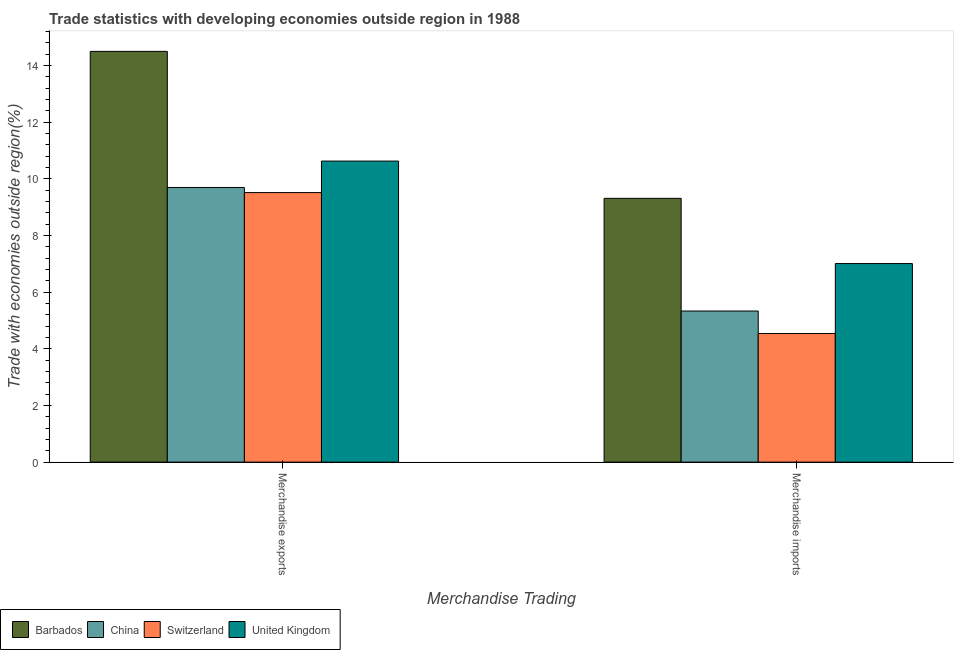How many groups of bars are there?
Keep it short and to the point. 2. Are the number of bars per tick equal to the number of legend labels?
Keep it short and to the point. Yes. How many bars are there on the 2nd tick from the left?
Provide a short and direct response. 4. What is the label of the 2nd group of bars from the left?
Make the answer very short. Merchandise imports. What is the merchandise imports in Switzerland?
Offer a terse response. 4.54. Across all countries, what is the maximum merchandise imports?
Offer a terse response. 9.31. Across all countries, what is the minimum merchandise imports?
Your answer should be very brief. 4.54. In which country was the merchandise exports maximum?
Your answer should be very brief. Barbados. In which country was the merchandise exports minimum?
Give a very brief answer. Switzerland. What is the total merchandise exports in the graph?
Keep it short and to the point. 44.32. What is the difference between the merchandise imports in United Kingdom and that in China?
Ensure brevity in your answer.  1.68. What is the difference between the merchandise exports in China and the merchandise imports in Barbados?
Make the answer very short. 0.38. What is the average merchandise imports per country?
Make the answer very short. 6.55. What is the difference between the merchandise exports and merchandise imports in Switzerland?
Make the answer very short. 4.97. In how many countries, is the merchandise exports greater than 12.4 %?
Keep it short and to the point. 1. What is the ratio of the merchandise exports in China to that in United Kingdom?
Give a very brief answer. 0.91. In how many countries, is the merchandise exports greater than the average merchandise exports taken over all countries?
Offer a very short reply. 1. What does the 3rd bar from the left in Merchandise imports represents?
Your response must be concise. Switzerland. What does the 3rd bar from the right in Merchandise exports represents?
Ensure brevity in your answer.  China. How many bars are there?
Provide a short and direct response. 8. Are all the bars in the graph horizontal?
Give a very brief answer. No. How many countries are there in the graph?
Your response must be concise. 4. Does the graph contain any zero values?
Give a very brief answer. No. Does the graph contain grids?
Give a very brief answer. No. How many legend labels are there?
Give a very brief answer. 4. What is the title of the graph?
Your answer should be compact. Trade statistics with developing economies outside region in 1988. Does "Costa Rica" appear as one of the legend labels in the graph?
Give a very brief answer. No. What is the label or title of the X-axis?
Your answer should be compact. Merchandise Trading. What is the label or title of the Y-axis?
Provide a short and direct response. Trade with economies outside region(%). What is the Trade with economies outside region(%) in Barbados in Merchandise exports?
Your answer should be very brief. 14.49. What is the Trade with economies outside region(%) in China in Merchandise exports?
Your answer should be very brief. 9.69. What is the Trade with economies outside region(%) in Switzerland in Merchandise exports?
Give a very brief answer. 9.51. What is the Trade with economies outside region(%) of United Kingdom in Merchandise exports?
Make the answer very short. 10.62. What is the Trade with economies outside region(%) in Barbados in Merchandise imports?
Ensure brevity in your answer.  9.31. What is the Trade with economies outside region(%) of China in Merchandise imports?
Provide a succinct answer. 5.33. What is the Trade with economies outside region(%) in Switzerland in Merchandise imports?
Your answer should be very brief. 4.54. What is the Trade with economies outside region(%) in United Kingdom in Merchandise imports?
Offer a terse response. 7.01. Across all Merchandise Trading, what is the maximum Trade with economies outside region(%) of Barbados?
Your response must be concise. 14.49. Across all Merchandise Trading, what is the maximum Trade with economies outside region(%) of China?
Offer a very short reply. 9.69. Across all Merchandise Trading, what is the maximum Trade with economies outside region(%) of Switzerland?
Give a very brief answer. 9.51. Across all Merchandise Trading, what is the maximum Trade with economies outside region(%) in United Kingdom?
Give a very brief answer. 10.62. Across all Merchandise Trading, what is the minimum Trade with economies outside region(%) of Barbados?
Offer a terse response. 9.31. Across all Merchandise Trading, what is the minimum Trade with economies outside region(%) of China?
Your response must be concise. 5.33. Across all Merchandise Trading, what is the minimum Trade with economies outside region(%) in Switzerland?
Your answer should be compact. 4.54. Across all Merchandise Trading, what is the minimum Trade with economies outside region(%) in United Kingdom?
Keep it short and to the point. 7.01. What is the total Trade with economies outside region(%) of Barbados in the graph?
Ensure brevity in your answer.  23.8. What is the total Trade with economies outside region(%) in China in the graph?
Offer a terse response. 15.02. What is the total Trade with economies outside region(%) of Switzerland in the graph?
Give a very brief answer. 14.05. What is the total Trade with economies outside region(%) in United Kingdom in the graph?
Ensure brevity in your answer.  17.63. What is the difference between the Trade with economies outside region(%) in Barbados in Merchandise exports and that in Merchandise imports?
Make the answer very short. 5.19. What is the difference between the Trade with economies outside region(%) of China in Merchandise exports and that in Merchandise imports?
Provide a short and direct response. 4.36. What is the difference between the Trade with economies outside region(%) in Switzerland in Merchandise exports and that in Merchandise imports?
Your answer should be compact. 4.97. What is the difference between the Trade with economies outside region(%) of United Kingdom in Merchandise exports and that in Merchandise imports?
Provide a succinct answer. 3.62. What is the difference between the Trade with economies outside region(%) in Barbados in Merchandise exports and the Trade with economies outside region(%) in China in Merchandise imports?
Make the answer very short. 9.16. What is the difference between the Trade with economies outside region(%) in Barbados in Merchandise exports and the Trade with economies outside region(%) in Switzerland in Merchandise imports?
Make the answer very short. 9.96. What is the difference between the Trade with economies outside region(%) of Barbados in Merchandise exports and the Trade with economies outside region(%) of United Kingdom in Merchandise imports?
Give a very brief answer. 7.49. What is the difference between the Trade with economies outside region(%) in China in Merchandise exports and the Trade with economies outside region(%) in Switzerland in Merchandise imports?
Keep it short and to the point. 5.15. What is the difference between the Trade with economies outside region(%) in China in Merchandise exports and the Trade with economies outside region(%) in United Kingdom in Merchandise imports?
Provide a short and direct response. 2.68. What is the difference between the Trade with economies outside region(%) of Switzerland in Merchandise exports and the Trade with economies outside region(%) of United Kingdom in Merchandise imports?
Your answer should be compact. 2.5. What is the average Trade with economies outside region(%) in Barbados per Merchandise Trading?
Make the answer very short. 11.9. What is the average Trade with economies outside region(%) in China per Merchandise Trading?
Provide a short and direct response. 7.51. What is the average Trade with economies outside region(%) of Switzerland per Merchandise Trading?
Offer a very short reply. 7.03. What is the average Trade with economies outside region(%) of United Kingdom per Merchandise Trading?
Offer a very short reply. 8.81. What is the difference between the Trade with economies outside region(%) of Barbados and Trade with economies outside region(%) of China in Merchandise exports?
Keep it short and to the point. 4.8. What is the difference between the Trade with economies outside region(%) of Barbados and Trade with economies outside region(%) of Switzerland in Merchandise exports?
Offer a terse response. 4.98. What is the difference between the Trade with economies outside region(%) in Barbados and Trade with economies outside region(%) in United Kingdom in Merchandise exports?
Give a very brief answer. 3.87. What is the difference between the Trade with economies outside region(%) in China and Trade with economies outside region(%) in Switzerland in Merchandise exports?
Your response must be concise. 0.18. What is the difference between the Trade with economies outside region(%) of China and Trade with economies outside region(%) of United Kingdom in Merchandise exports?
Offer a terse response. -0.93. What is the difference between the Trade with economies outside region(%) of Switzerland and Trade with economies outside region(%) of United Kingdom in Merchandise exports?
Your answer should be compact. -1.11. What is the difference between the Trade with economies outside region(%) of Barbados and Trade with economies outside region(%) of China in Merchandise imports?
Give a very brief answer. 3.98. What is the difference between the Trade with economies outside region(%) in Barbados and Trade with economies outside region(%) in Switzerland in Merchandise imports?
Your response must be concise. 4.77. What is the difference between the Trade with economies outside region(%) of Barbados and Trade with economies outside region(%) of United Kingdom in Merchandise imports?
Keep it short and to the point. 2.3. What is the difference between the Trade with economies outside region(%) in China and Trade with economies outside region(%) in Switzerland in Merchandise imports?
Your answer should be very brief. 0.79. What is the difference between the Trade with economies outside region(%) of China and Trade with economies outside region(%) of United Kingdom in Merchandise imports?
Give a very brief answer. -1.68. What is the difference between the Trade with economies outside region(%) in Switzerland and Trade with economies outside region(%) in United Kingdom in Merchandise imports?
Your response must be concise. -2.47. What is the ratio of the Trade with economies outside region(%) of Barbados in Merchandise exports to that in Merchandise imports?
Provide a short and direct response. 1.56. What is the ratio of the Trade with economies outside region(%) of China in Merchandise exports to that in Merchandise imports?
Provide a short and direct response. 1.82. What is the ratio of the Trade with economies outside region(%) in Switzerland in Merchandise exports to that in Merchandise imports?
Your response must be concise. 2.1. What is the ratio of the Trade with economies outside region(%) of United Kingdom in Merchandise exports to that in Merchandise imports?
Keep it short and to the point. 1.52. What is the difference between the highest and the second highest Trade with economies outside region(%) in Barbados?
Keep it short and to the point. 5.19. What is the difference between the highest and the second highest Trade with economies outside region(%) of China?
Your answer should be very brief. 4.36. What is the difference between the highest and the second highest Trade with economies outside region(%) of Switzerland?
Provide a short and direct response. 4.97. What is the difference between the highest and the second highest Trade with economies outside region(%) in United Kingdom?
Your answer should be very brief. 3.62. What is the difference between the highest and the lowest Trade with economies outside region(%) of Barbados?
Your answer should be very brief. 5.19. What is the difference between the highest and the lowest Trade with economies outside region(%) of China?
Provide a succinct answer. 4.36. What is the difference between the highest and the lowest Trade with economies outside region(%) of Switzerland?
Your answer should be compact. 4.97. What is the difference between the highest and the lowest Trade with economies outside region(%) of United Kingdom?
Make the answer very short. 3.62. 